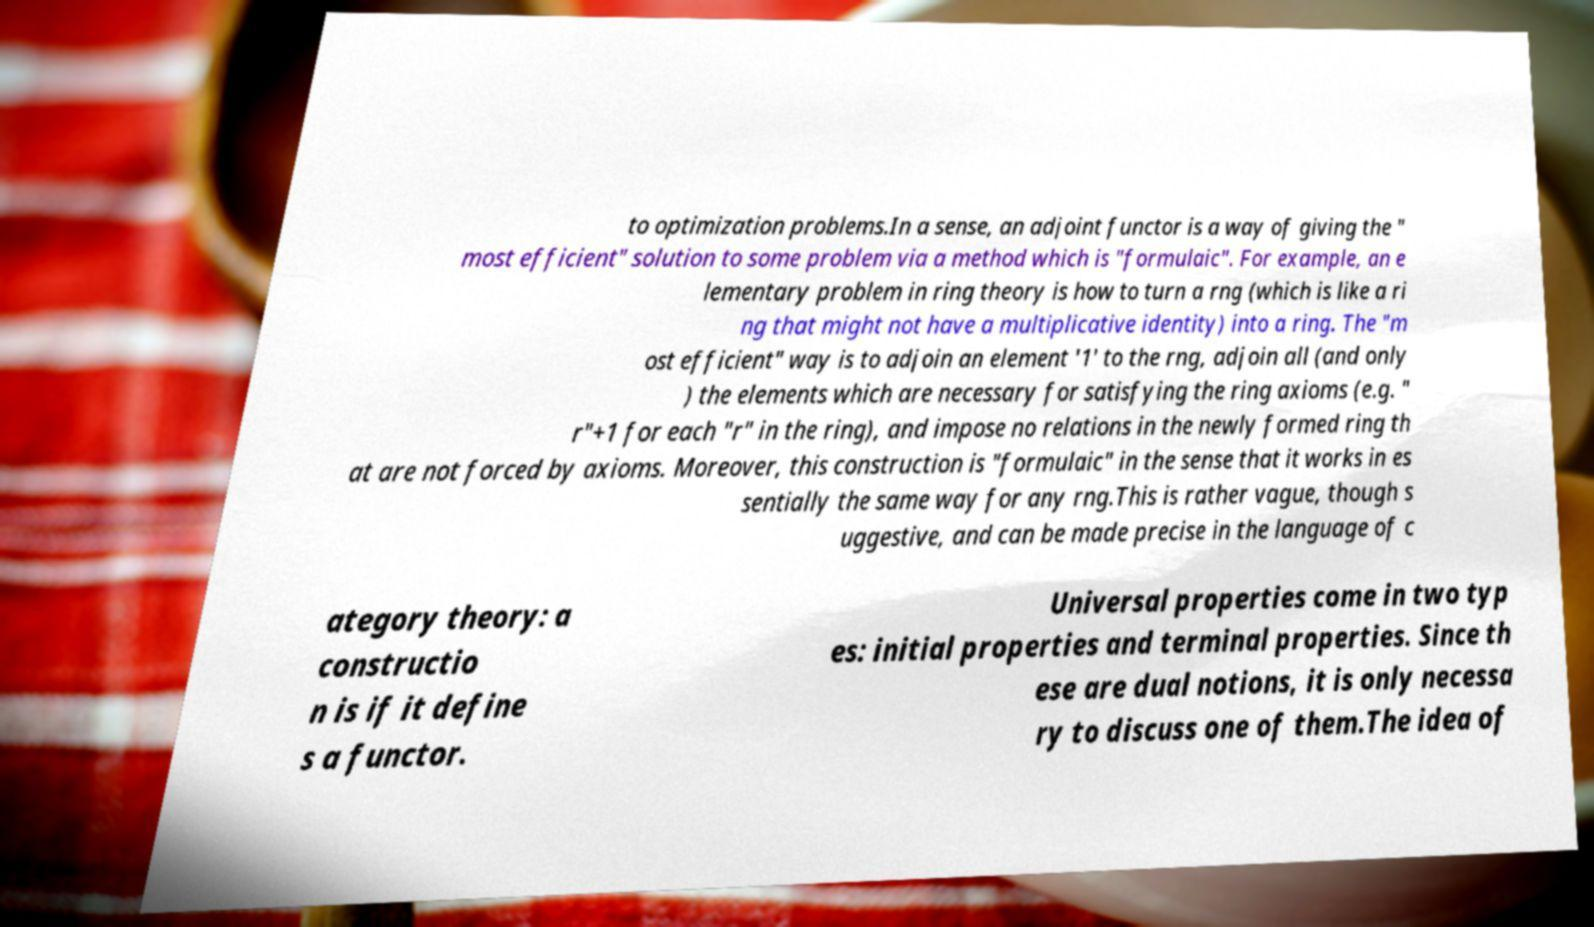Could you assist in decoding the text presented in this image and type it out clearly? to optimization problems.In a sense, an adjoint functor is a way of giving the " most efficient" solution to some problem via a method which is "formulaic". For example, an e lementary problem in ring theory is how to turn a rng (which is like a ri ng that might not have a multiplicative identity) into a ring. The "m ost efficient" way is to adjoin an element '1' to the rng, adjoin all (and only ) the elements which are necessary for satisfying the ring axioms (e.g. " r"+1 for each "r" in the ring), and impose no relations in the newly formed ring th at are not forced by axioms. Moreover, this construction is "formulaic" in the sense that it works in es sentially the same way for any rng.This is rather vague, though s uggestive, and can be made precise in the language of c ategory theory: a constructio n is if it define s a functor. Universal properties come in two typ es: initial properties and terminal properties. Since th ese are dual notions, it is only necessa ry to discuss one of them.The idea of 